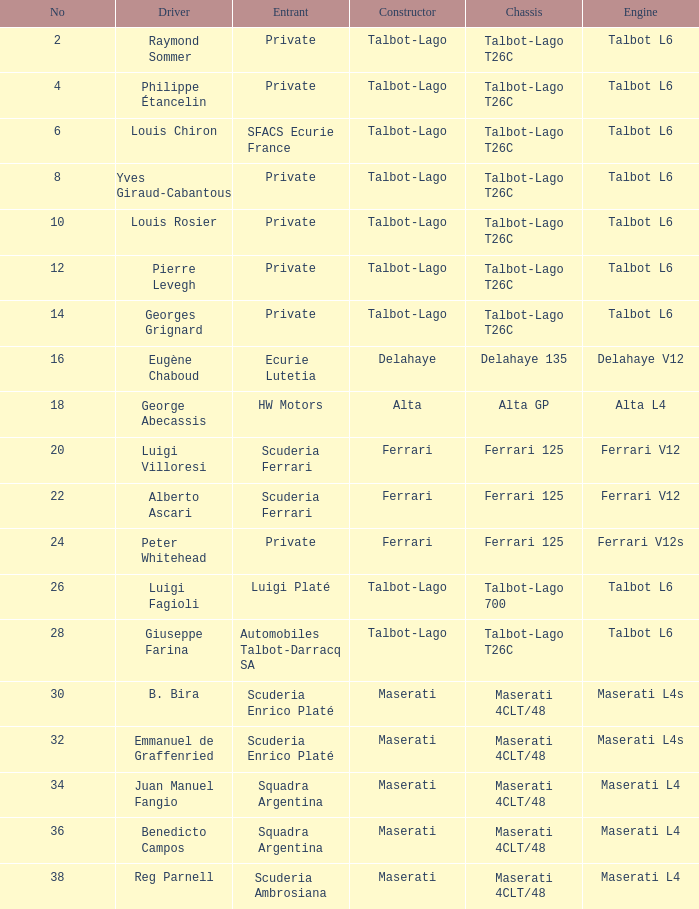Name the constructor for b. bira Maserati. 